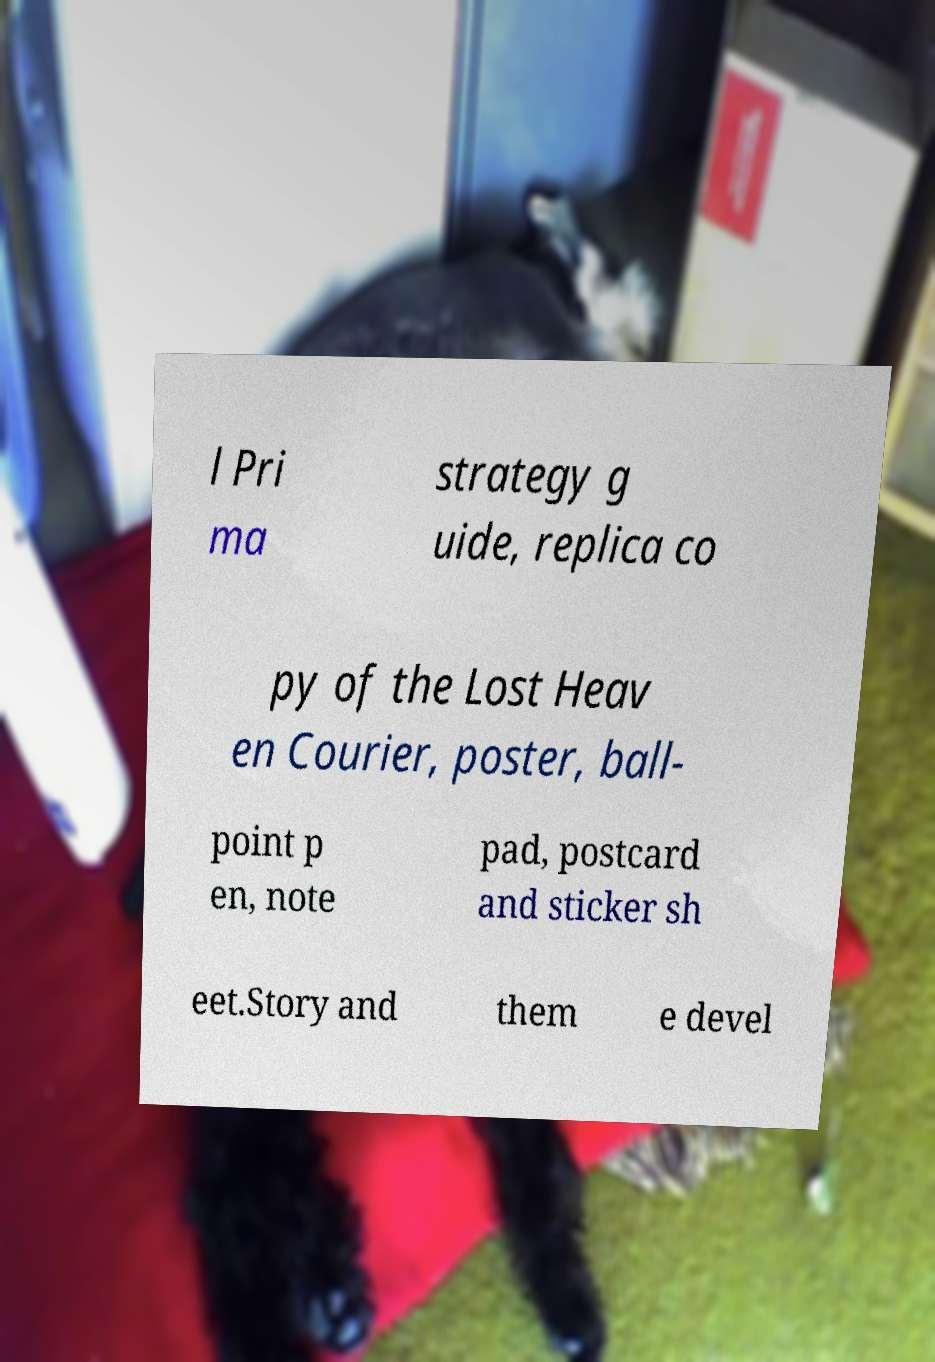Could you extract and type out the text from this image? l Pri ma strategy g uide, replica co py of the Lost Heav en Courier, poster, ball- point p en, note pad, postcard and sticker sh eet.Story and them e devel 